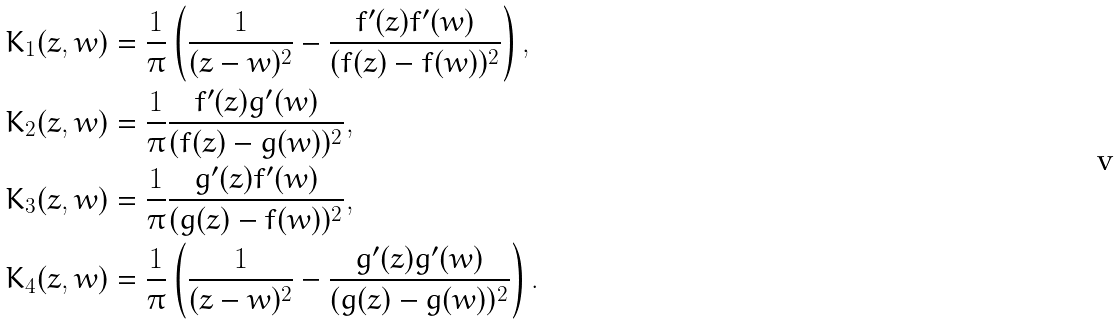Convert formula to latex. <formula><loc_0><loc_0><loc_500><loc_500>K _ { 1 } ( z , w ) & = \frac { 1 } { \pi } \left ( \frac { 1 } { ( z - w ) ^ { 2 } } - \frac { f ^ { \prime } ( z ) f ^ { \prime } ( w ) } { ( f ( z ) - f ( w ) ) ^ { 2 } } \right ) , \\ K _ { 2 } ( z , w ) & = \frac { 1 } { \pi } \frac { f ^ { \prime } ( z ) g ^ { \prime } ( w ) } { ( f ( z ) - g ( w ) ) ^ { 2 } } , \\ K _ { 3 } ( z , w ) & = \frac { 1 } { \pi } \frac { g ^ { \prime } ( z ) f ^ { \prime } ( w ) } { ( g ( z ) - f ( w ) ) ^ { 2 } } , \\ K _ { 4 } ( z , w ) & = \frac { 1 } { \pi } \left ( \frac { 1 } { ( z - w ) ^ { 2 } } - \frac { g ^ { \prime } ( z ) g ^ { \prime } ( w ) } { ( g ( z ) - g ( w ) ) ^ { 2 } } \right ) .</formula> 